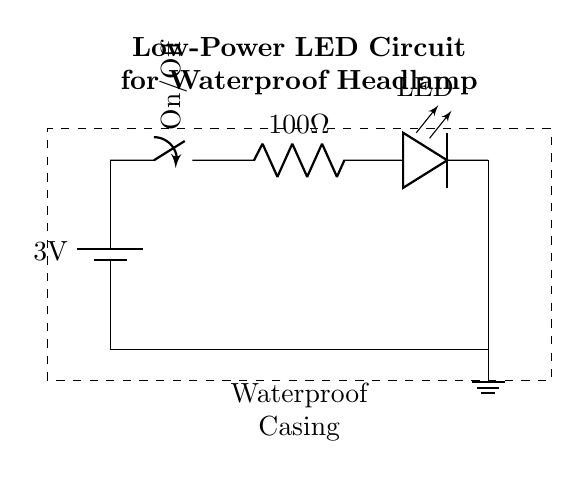What is the voltage supplied by the battery? The voltage supplied by the battery is indicated as 3V in the circuit diagram. This is identified by reading the label on the battery symbol.
Answer: 3 volts What component is used to control the flow of electricity? The component used to control the flow of electricity is a switch. This is identified in the circuit as the element labeled "On/Off" which allows the circuit to be either open or closed.
Answer: Switch What is the resistance value in the circuit? The resistance value in the circuit is labeled as 100 ohms. This is derived from the symbol for resistance, which shows the value next to it in the circuit diagram.
Answer: 100 ohms What is the function of the LED in this circuit? The LED functions as an indicator light, showing that the circuit is complete and current is flowing when the switch is closed. This is inferred from the standard role of LEDs in circuits.
Answer: Indicator light What happens when the switch is turned off? When the switch is turned off, the circuit is interrupted, causing the LED to turn off and stopping current flow. This is understood by recognizing that an open switch prevents the flow of electricity.
Answer: LED turns off What does the dashed rectangle represent? The dashed rectangle represents the waterproof casing, indicating that the components are housed in a protective enclosure suitable for outdoor or wet conditions. This is indicated by the label inside the dashed outline.
Answer: Waterproof casing What type of circuit is this? This is a low-power LED circuit. This can be concluded from the use of minimal voltage and the presence of an LED designed for low power applications.
Answer: Low-power LED circuit 